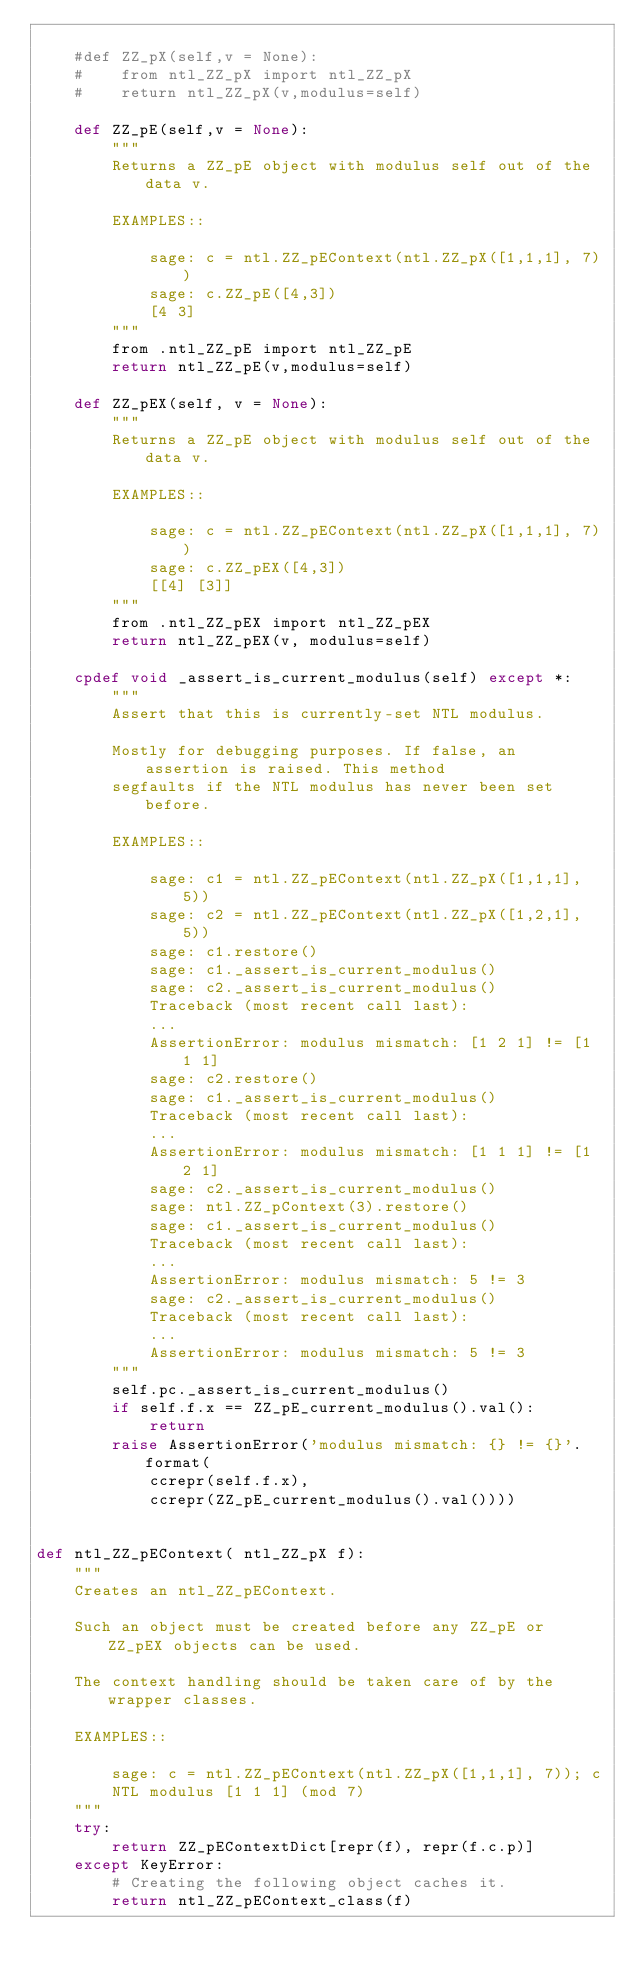Convert code to text. <code><loc_0><loc_0><loc_500><loc_500><_Cython_>
    #def ZZ_pX(self,v = None):
    #    from ntl_ZZ_pX import ntl_ZZ_pX
    #    return ntl_ZZ_pX(v,modulus=self)

    def ZZ_pE(self,v = None):
        """
        Returns a ZZ_pE object with modulus self out of the data v.

        EXAMPLES::

            sage: c = ntl.ZZ_pEContext(ntl.ZZ_pX([1,1,1], 7))
            sage: c.ZZ_pE([4,3])
            [4 3]
        """
        from .ntl_ZZ_pE import ntl_ZZ_pE
        return ntl_ZZ_pE(v,modulus=self)

    def ZZ_pEX(self, v = None):
        """
        Returns a ZZ_pE object with modulus self out of the data v.

        EXAMPLES::

            sage: c = ntl.ZZ_pEContext(ntl.ZZ_pX([1,1,1], 7))
            sage: c.ZZ_pEX([4,3])
            [[4] [3]]
        """
        from .ntl_ZZ_pEX import ntl_ZZ_pEX
        return ntl_ZZ_pEX(v, modulus=self)

    cpdef void _assert_is_current_modulus(self) except *:
        """
        Assert that this is currently-set NTL modulus.

        Mostly for debugging purposes. If false, an assertion is raised. This method
        segfaults if the NTL modulus has never been set before.

        EXAMPLES::

            sage: c1 = ntl.ZZ_pEContext(ntl.ZZ_pX([1,1,1], 5))
            sage: c2 = ntl.ZZ_pEContext(ntl.ZZ_pX([1,2,1], 5))
            sage: c1.restore()
            sage: c1._assert_is_current_modulus()
            sage: c2._assert_is_current_modulus()
            Traceback (most recent call last):
            ...
            AssertionError: modulus mismatch: [1 2 1] != [1 1 1]
            sage: c2.restore()
            sage: c1._assert_is_current_modulus()
            Traceback (most recent call last):
            ...
            AssertionError: modulus mismatch: [1 1 1] != [1 2 1]
            sage: c2._assert_is_current_modulus()
            sage: ntl.ZZ_pContext(3).restore()
            sage: c1._assert_is_current_modulus()
            Traceback (most recent call last):
            ...
            AssertionError: modulus mismatch: 5 != 3
            sage: c2._assert_is_current_modulus()
            Traceback (most recent call last):
            ...
            AssertionError: modulus mismatch: 5 != 3
        """
        self.pc._assert_is_current_modulus()
        if self.f.x == ZZ_pE_current_modulus().val():
            return
        raise AssertionError('modulus mismatch: {} != {}'.format(
            ccrepr(self.f.x),
            ccrepr(ZZ_pE_current_modulus().val())))


def ntl_ZZ_pEContext( ntl_ZZ_pX f):
    """
    Creates an ntl_ZZ_pEContext.

    Such an object must be created before any ZZ_pE or ZZ_pEX objects can be used.

    The context handling should be taken care of by the wrapper classes.

    EXAMPLES::

        sage: c = ntl.ZZ_pEContext(ntl.ZZ_pX([1,1,1], 7)); c
        NTL modulus [1 1 1] (mod 7)
    """
    try:
        return ZZ_pEContextDict[repr(f), repr(f.c.p)]
    except KeyError:
        # Creating the following object caches it.
        return ntl_ZZ_pEContext_class(f)
</code> 